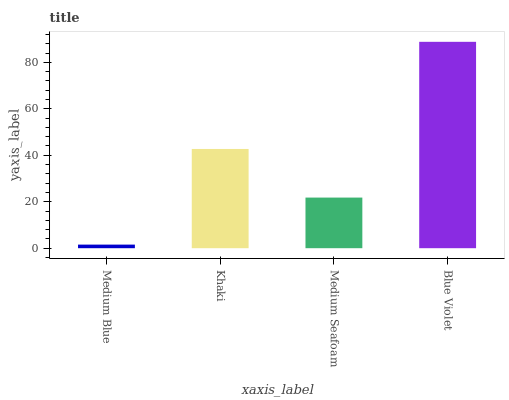Is Khaki the minimum?
Answer yes or no. No. Is Khaki the maximum?
Answer yes or no. No. Is Khaki greater than Medium Blue?
Answer yes or no. Yes. Is Medium Blue less than Khaki?
Answer yes or no. Yes. Is Medium Blue greater than Khaki?
Answer yes or no. No. Is Khaki less than Medium Blue?
Answer yes or no. No. Is Khaki the high median?
Answer yes or no. Yes. Is Medium Seafoam the low median?
Answer yes or no. Yes. Is Medium Blue the high median?
Answer yes or no. No. Is Medium Blue the low median?
Answer yes or no. No. 